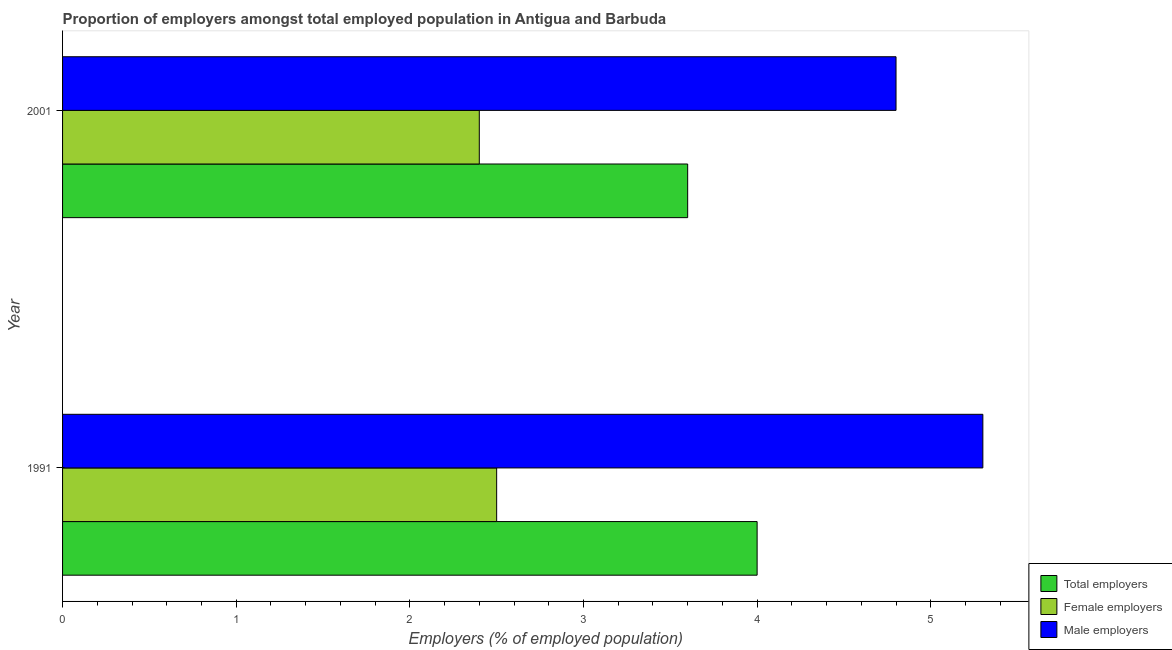How many groups of bars are there?
Provide a short and direct response. 2. Are the number of bars per tick equal to the number of legend labels?
Your answer should be compact. Yes. Are the number of bars on each tick of the Y-axis equal?
Your answer should be very brief. Yes. How many bars are there on the 1st tick from the top?
Ensure brevity in your answer.  3. In how many cases, is the number of bars for a given year not equal to the number of legend labels?
Provide a succinct answer. 0. What is the percentage of male employers in 2001?
Ensure brevity in your answer.  4.8. Across all years, what is the maximum percentage of male employers?
Offer a very short reply. 5.3. Across all years, what is the minimum percentage of female employers?
Provide a succinct answer. 2.4. What is the total percentage of male employers in the graph?
Give a very brief answer. 10.1. What is the difference between the percentage of total employers in 1991 and that in 2001?
Provide a succinct answer. 0.4. What is the difference between the percentage of female employers in 1991 and the percentage of total employers in 2001?
Your answer should be compact. -1.1. What is the average percentage of male employers per year?
Keep it short and to the point. 5.05. What is the ratio of the percentage of male employers in 1991 to that in 2001?
Provide a short and direct response. 1.1. Is the percentage of total employers in 1991 less than that in 2001?
Offer a terse response. No. Is the difference between the percentage of male employers in 1991 and 2001 greater than the difference between the percentage of female employers in 1991 and 2001?
Offer a terse response. Yes. In how many years, is the percentage of total employers greater than the average percentage of total employers taken over all years?
Keep it short and to the point. 1. What does the 2nd bar from the top in 1991 represents?
Ensure brevity in your answer.  Female employers. What does the 1st bar from the bottom in 1991 represents?
Make the answer very short. Total employers. Is it the case that in every year, the sum of the percentage of total employers and percentage of female employers is greater than the percentage of male employers?
Offer a very short reply. Yes. How many years are there in the graph?
Provide a short and direct response. 2. Are the values on the major ticks of X-axis written in scientific E-notation?
Make the answer very short. No. Does the graph contain any zero values?
Your response must be concise. No. How are the legend labels stacked?
Make the answer very short. Vertical. What is the title of the graph?
Offer a terse response. Proportion of employers amongst total employed population in Antigua and Barbuda. What is the label or title of the X-axis?
Offer a very short reply. Employers (% of employed population). What is the Employers (% of employed population) in Total employers in 1991?
Your answer should be very brief. 4. What is the Employers (% of employed population) in Male employers in 1991?
Give a very brief answer. 5.3. What is the Employers (% of employed population) of Total employers in 2001?
Provide a short and direct response. 3.6. What is the Employers (% of employed population) in Female employers in 2001?
Your answer should be compact. 2.4. What is the Employers (% of employed population) of Male employers in 2001?
Offer a terse response. 4.8. Across all years, what is the maximum Employers (% of employed population) in Male employers?
Give a very brief answer. 5.3. Across all years, what is the minimum Employers (% of employed population) in Total employers?
Your answer should be very brief. 3.6. Across all years, what is the minimum Employers (% of employed population) of Female employers?
Provide a succinct answer. 2.4. Across all years, what is the minimum Employers (% of employed population) of Male employers?
Offer a terse response. 4.8. What is the total Employers (% of employed population) in Total employers in the graph?
Keep it short and to the point. 7.6. What is the total Employers (% of employed population) in Male employers in the graph?
Give a very brief answer. 10.1. What is the difference between the Employers (% of employed population) in Total employers in 1991 and that in 2001?
Your answer should be very brief. 0.4. What is the average Employers (% of employed population) in Female employers per year?
Ensure brevity in your answer.  2.45. What is the average Employers (% of employed population) of Male employers per year?
Keep it short and to the point. 5.05. In the year 2001, what is the difference between the Employers (% of employed population) in Total employers and Employers (% of employed population) in Male employers?
Offer a very short reply. -1.2. In the year 2001, what is the difference between the Employers (% of employed population) in Female employers and Employers (% of employed population) in Male employers?
Offer a terse response. -2.4. What is the ratio of the Employers (% of employed population) of Female employers in 1991 to that in 2001?
Make the answer very short. 1.04. What is the ratio of the Employers (% of employed population) in Male employers in 1991 to that in 2001?
Give a very brief answer. 1.1. What is the difference between the highest and the second highest Employers (% of employed population) in Male employers?
Offer a very short reply. 0.5. What is the difference between the highest and the lowest Employers (% of employed population) in Total employers?
Your answer should be very brief. 0.4. What is the difference between the highest and the lowest Employers (% of employed population) of Male employers?
Give a very brief answer. 0.5. 